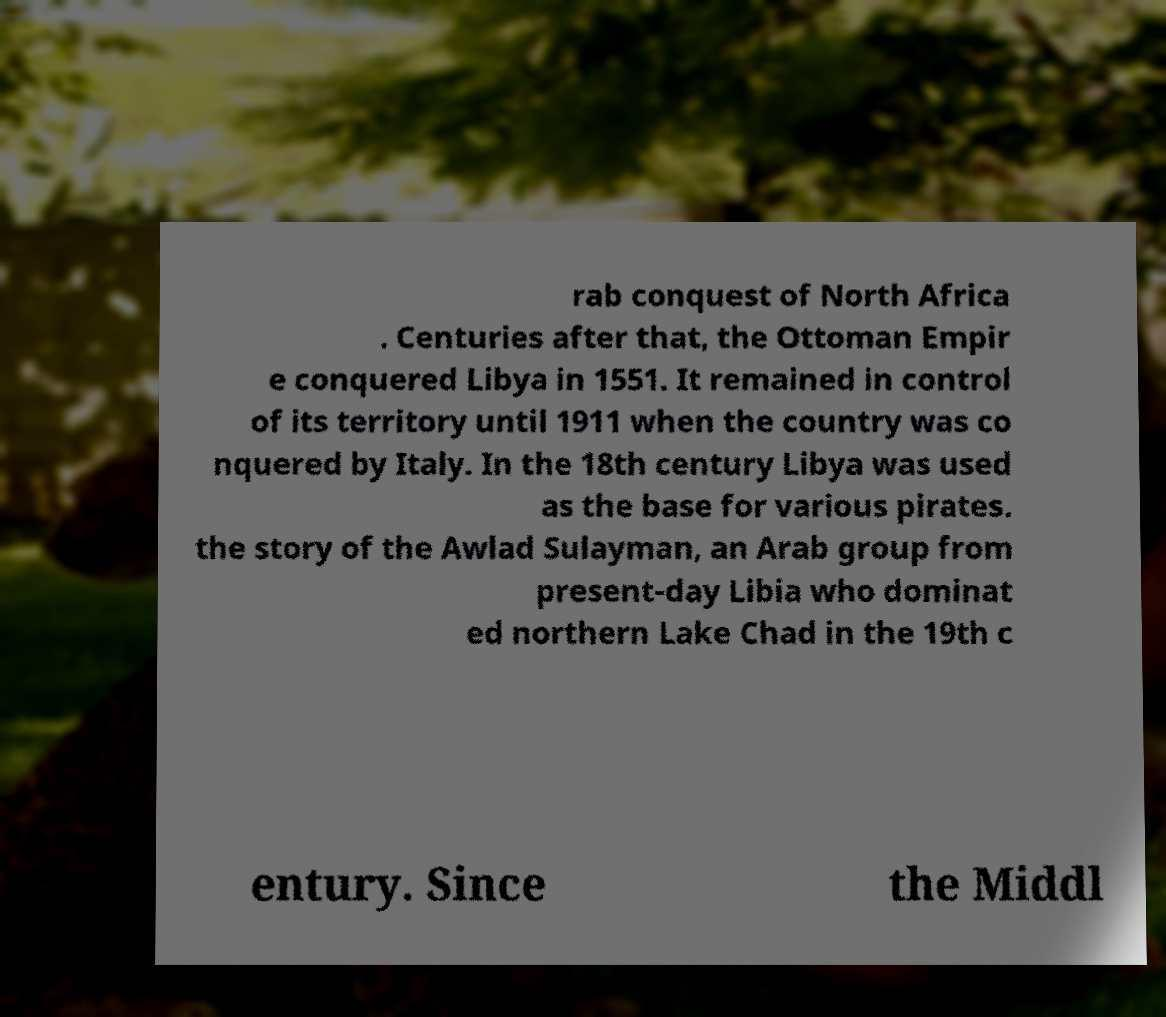What messages or text are displayed in this image? I need them in a readable, typed format. rab conquest of North Africa . Centuries after that, the Ottoman Empir e conquered Libya in 1551. It remained in control of its territory until 1911 when the country was co nquered by Italy. In the 18th century Libya was used as the base for various pirates. the story of the Awlad Sulayman, an Arab group from present-day Libia who dominat ed northern Lake Chad in the 19th c entury. Since the Middl 